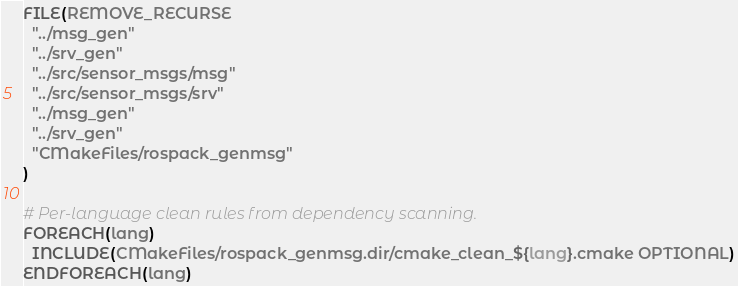Convert code to text. <code><loc_0><loc_0><loc_500><loc_500><_CMake_>FILE(REMOVE_RECURSE
  "../msg_gen"
  "../srv_gen"
  "../src/sensor_msgs/msg"
  "../src/sensor_msgs/srv"
  "../msg_gen"
  "../srv_gen"
  "CMakeFiles/rospack_genmsg"
)

# Per-language clean rules from dependency scanning.
FOREACH(lang)
  INCLUDE(CMakeFiles/rospack_genmsg.dir/cmake_clean_${lang}.cmake OPTIONAL)
ENDFOREACH(lang)
</code> 